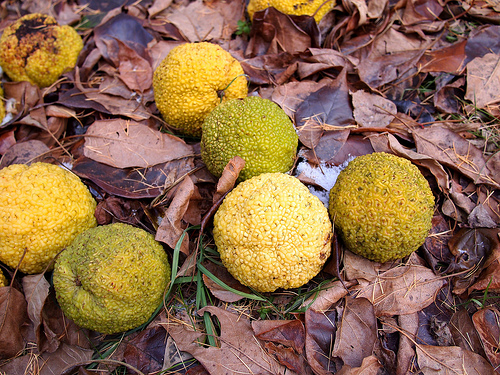<image>
Is the green fruit next to the yellow fruit? Yes. The green fruit is positioned adjacent to the yellow fruit, located nearby in the same general area. 